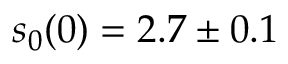Convert formula to latex. <formula><loc_0><loc_0><loc_500><loc_500>s _ { 0 } ( 0 ) = 2 . 7 \pm 0 . 1</formula> 